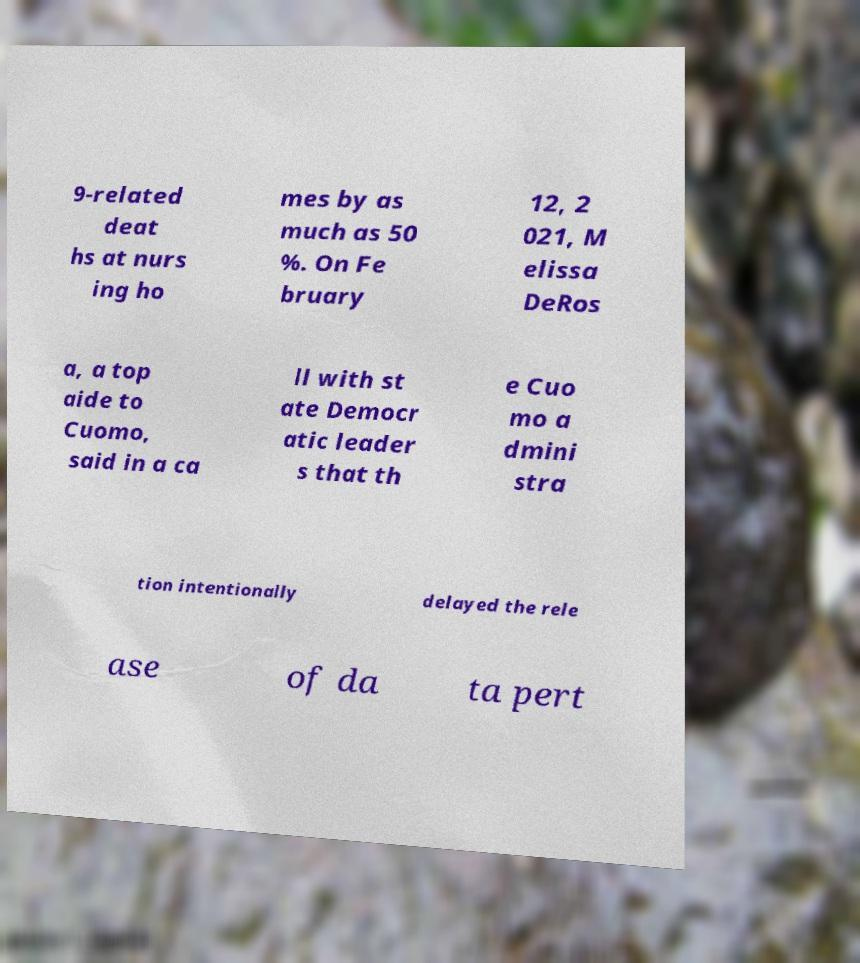Could you extract and type out the text from this image? 9-related deat hs at nurs ing ho mes by as much as 50 %. On Fe bruary 12, 2 021, M elissa DeRos a, a top aide to Cuomo, said in a ca ll with st ate Democr atic leader s that th e Cuo mo a dmini stra tion intentionally delayed the rele ase of da ta pert 